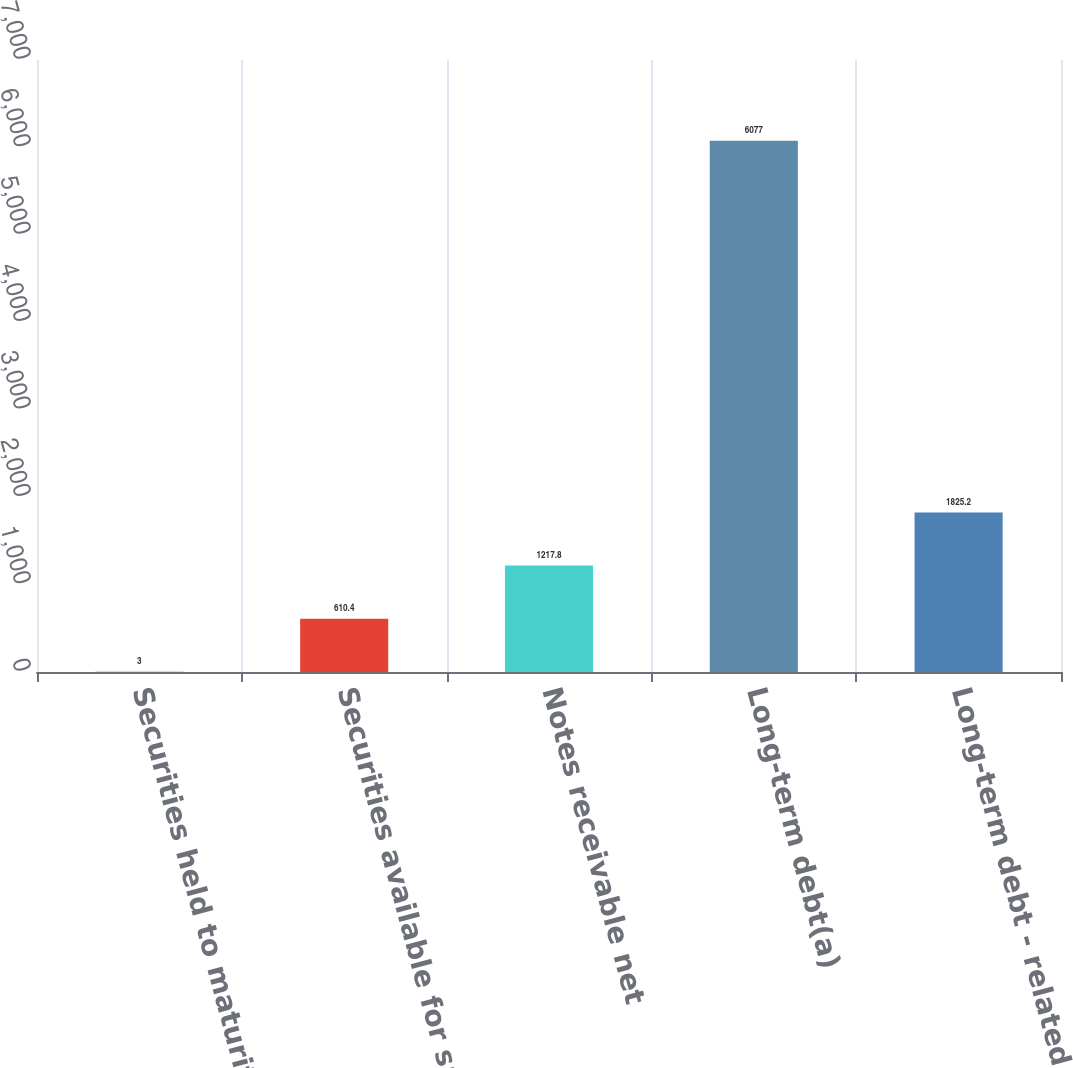Convert chart. <chart><loc_0><loc_0><loc_500><loc_500><bar_chart><fcel>Securities held to maturity<fcel>Securities available for sale<fcel>Notes receivable net<fcel>Long-term debt(a)<fcel>Long-term debt - related<nl><fcel>3<fcel>610.4<fcel>1217.8<fcel>6077<fcel>1825.2<nl></chart> 